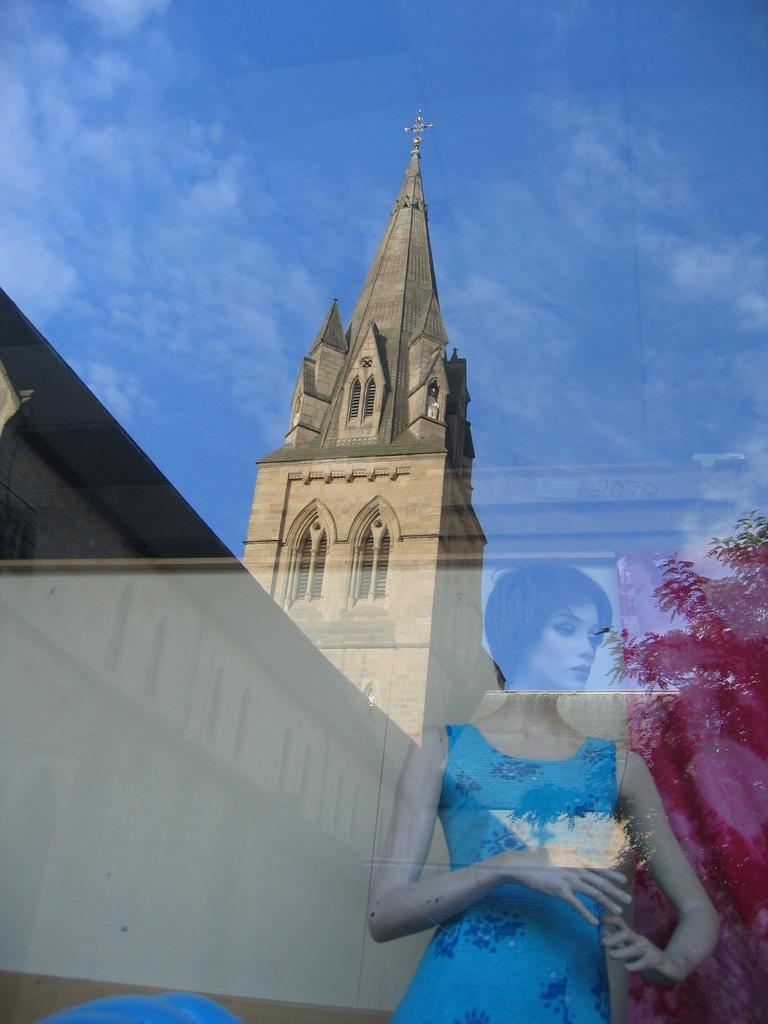What object is present in the image that is typically used for holding liquids? There is a glass in the image. What is located behind the glass in the image? There is a mannequin behind the glass. What images can be seen on the glass? A church, a tree, and the sky are visible on the glass. Is there a soap dispenser visible in the image? No, there is no soap dispenser mentioned in the facts provided. Can you describe the rainstorm that is happening in the image? There is no mention of a rainstorm in the facts provided, so it cannot be described. 